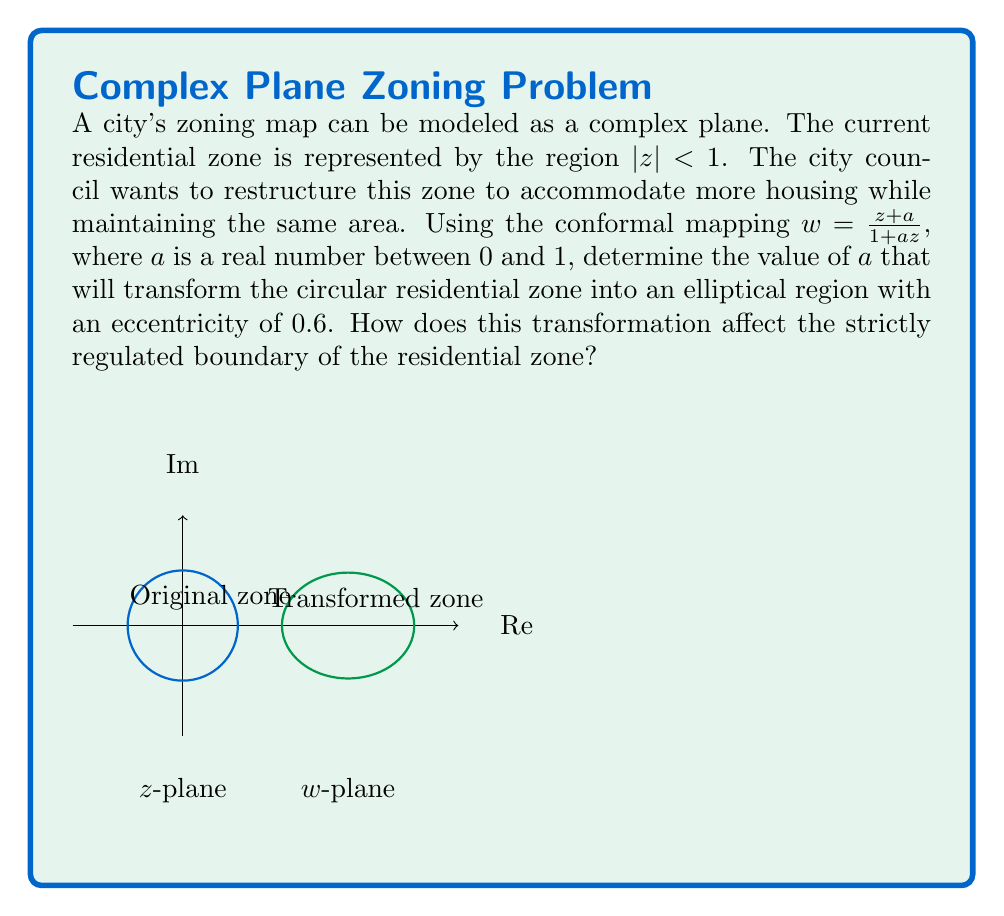Give your solution to this math problem. Let's approach this step-by-step:

1) The conformal mapping $w = \frac{z+a}{1+az}$ transforms the unit circle $|z| = 1$ into an ellipse in the $w$-plane.

2) The eccentricity $e$ of this ellipse is related to the parameter $a$ by the formula:

   $e = \frac{2a}{1+a^2}$

3) We're given that the eccentricity is 0.6, so we can set up the equation:

   $0.6 = \frac{2a}{1+a^2}$

4) Cross-multiplying:

   $0.6(1+a^2) = 2a$
   $0.6 + 0.6a^2 = 2a$

5) Rearranging:

   $0.6a^2 - 2a + 0.6 = 0$

6) This is a quadratic equation. We can solve it using the quadratic formula:

   $a = \frac{2 \pm \sqrt{4 - 4(0.6)(0.6)}}{2(0.6)}$

7) Simplifying:

   $a = \frac{2 \pm \sqrt{4 - 1.44}}{1.2} = \frac{2 \pm \sqrt{2.56}}{1.2} = \frac{2 \pm 1.6}{1.2}$

8) This gives us two solutions:

   $a = \frac{3.6}{1.2} = 3$ or $a = \frac{0.4}{1.2} = \frac{1}{3}$

9) Since we're told that $a$ is between 0 and 1, we must choose $a = \frac{1}{3}$.

10) This transformation affects the strictly regulated boundary of the residential zone by changing its shape from a circle to an ellipse, while preserving its area. The boundary points are moved, but in a way that maintains the overall zoning area.
Answer: $a = \frac{1}{3}$ 